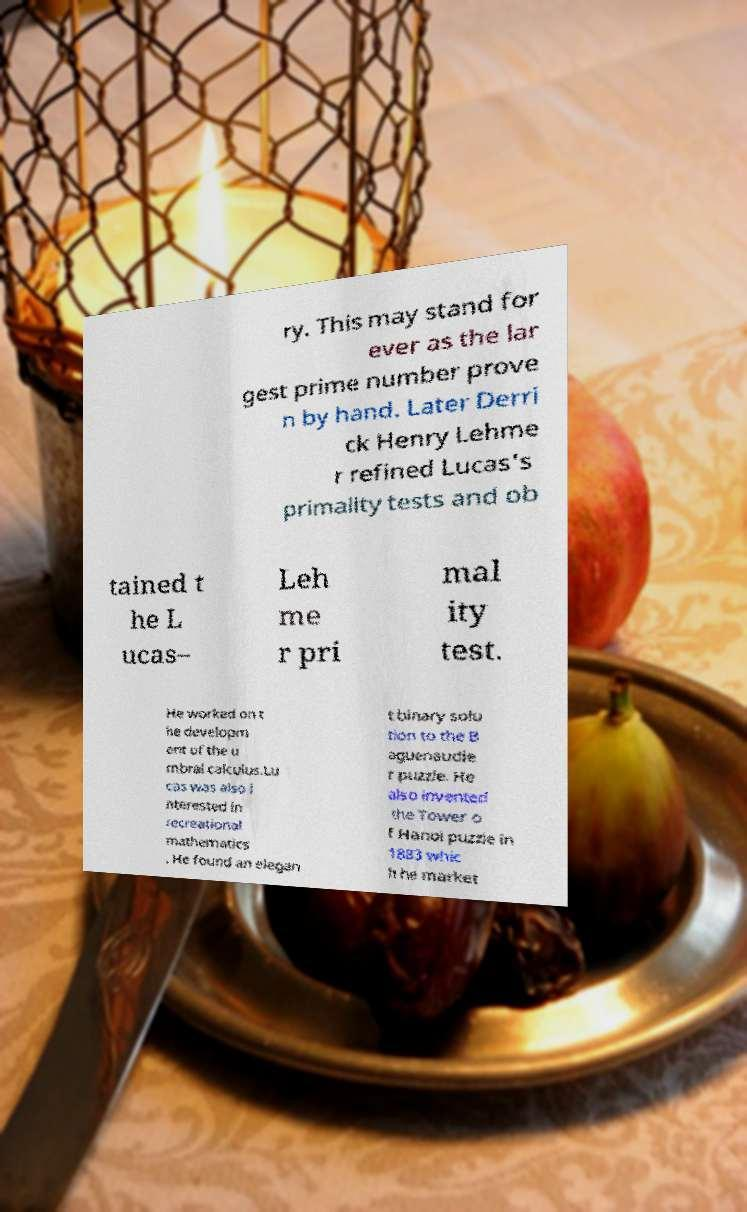Could you extract and type out the text from this image? ry. This may stand for ever as the lar gest prime number prove n by hand. Later Derri ck Henry Lehme r refined Lucas's primality tests and ob tained t he L ucas– Leh me r pri mal ity test. He worked on t he developm ent of the u mbral calculus.Lu cas was also i nterested in recreational mathematics . He found an elegan t binary solu tion to the B aguenaudie r puzzle. He also invented the Tower o f Hanoi puzzle in 1883 whic h he market 